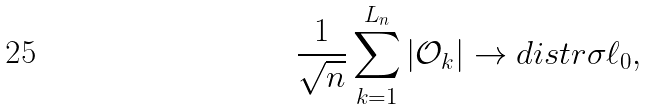<formula> <loc_0><loc_0><loc_500><loc_500>\frac { 1 } { \sqrt { n } } \sum _ { k = 1 } ^ { L _ { n } } | \mathcal { O } _ { k } | \to d i s t r \sigma \ell _ { 0 } ,</formula> 